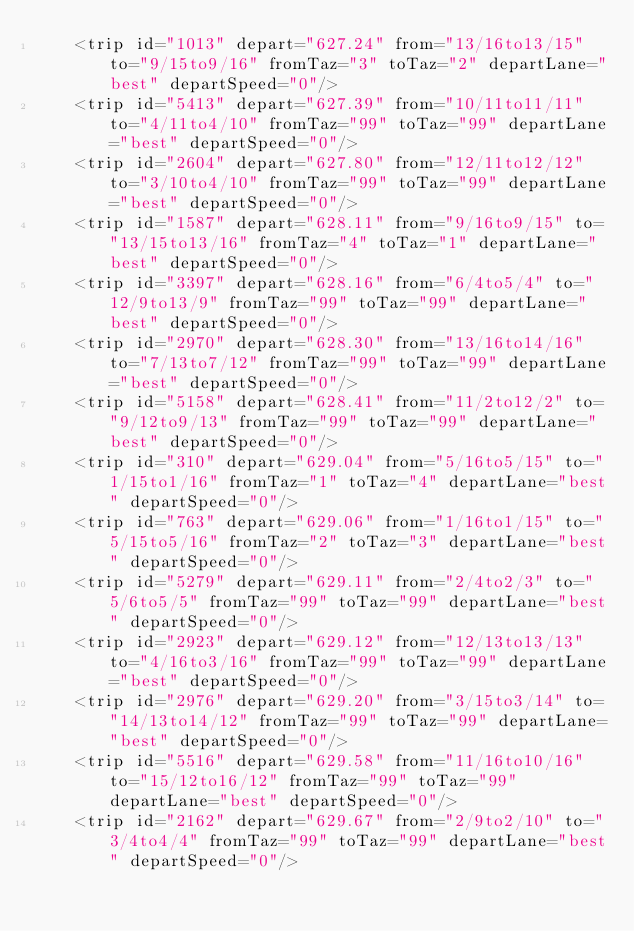<code> <loc_0><loc_0><loc_500><loc_500><_XML_>    <trip id="1013" depart="627.24" from="13/16to13/15" to="9/15to9/16" fromTaz="3" toTaz="2" departLane="best" departSpeed="0"/>
    <trip id="5413" depart="627.39" from="10/11to11/11" to="4/11to4/10" fromTaz="99" toTaz="99" departLane="best" departSpeed="0"/>
    <trip id="2604" depart="627.80" from="12/11to12/12" to="3/10to4/10" fromTaz="99" toTaz="99" departLane="best" departSpeed="0"/>
    <trip id="1587" depart="628.11" from="9/16to9/15" to="13/15to13/16" fromTaz="4" toTaz="1" departLane="best" departSpeed="0"/>
    <trip id="3397" depart="628.16" from="6/4to5/4" to="12/9to13/9" fromTaz="99" toTaz="99" departLane="best" departSpeed="0"/>
    <trip id="2970" depart="628.30" from="13/16to14/16" to="7/13to7/12" fromTaz="99" toTaz="99" departLane="best" departSpeed="0"/>
    <trip id="5158" depart="628.41" from="11/2to12/2" to="9/12to9/13" fromTaz="99" toTaz="99" departLane="best" departSpeed="0"/>
    <trip id="310" depart="629.04" from="5/16to5/15" to="1/15to1/16" fromTaz="1" toTaz="4" departLane="best" departSpeed="0"/>
    <trip id="763" depart="629.06" from="1/16to1/15" to="5/15to5/16" fromTaz="2" toTaz="3" departLane="best" departSpeed="0"/>
    <trip id="5279" depart="629.11" from="2/4to2/3" to="5/6to5/5" fromTaz="99" toTaz="99" departLane="best" departSpeed="0"/>
    <trip id="2923" depart="629.12" from="12/13to13/13" to="4/16to3/16" fromTaz="99" toTaz="99" departLane="best" departSpeed="0"/>
    <trip id="2976" depart="629.20" from="3/15to3/14" to="14/13to14/12" fromTaz="99" toTaz="99" departLane="best" departSpeed="0"/>
    <trip id="5516" depart="629.58" from="11/16to10/16" to="15/12to16/12" fromTaz="99" toTaz="99" departLane="best" departSpeed="0"/>
    <trip id="2162" depart="629.67" from="2/9to2/10" to="3/4to4/4" fromTaz="99" toTaz="99" departLane="best" departSpeed="0"/></code> 